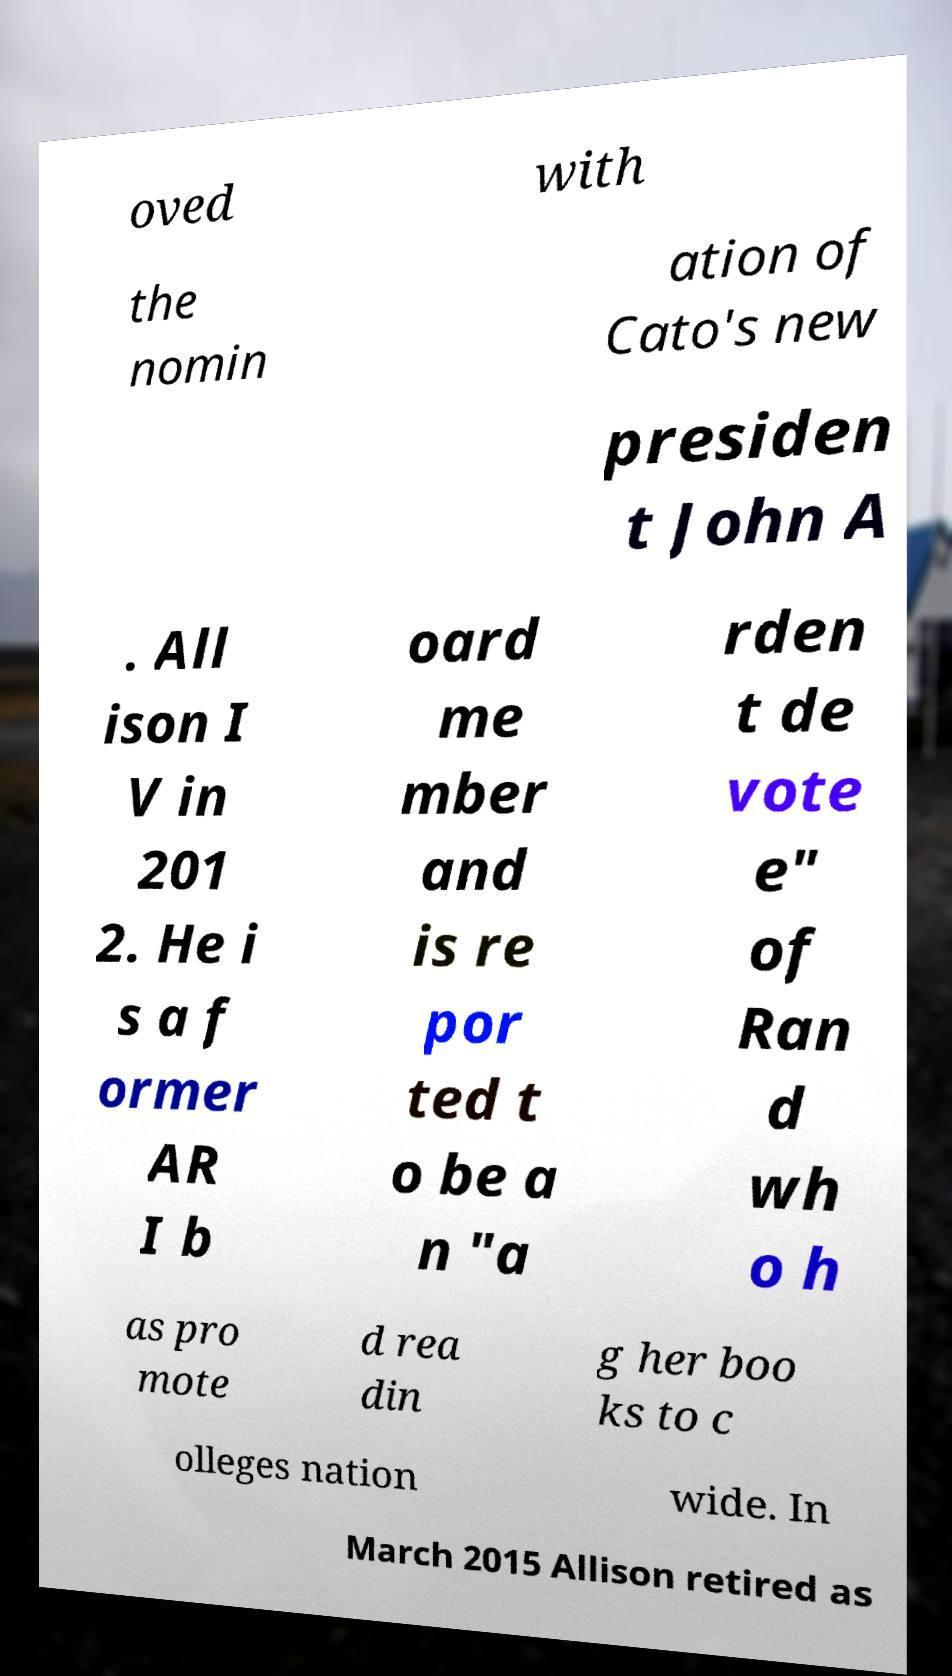What messages or text are displayed in this image? I need them in a readable, typed format. oved with the nomin ation of Cato's new presiden t John A . All ison I V in 201 2. He i s a f ormer AR I b oard me mber and is re por ted t o be a n "a rden t de vote e" of Ran d wh o h as pro mote d rea din g her boo ks to c olleges nation wide. In March 2015 Allison retired as 